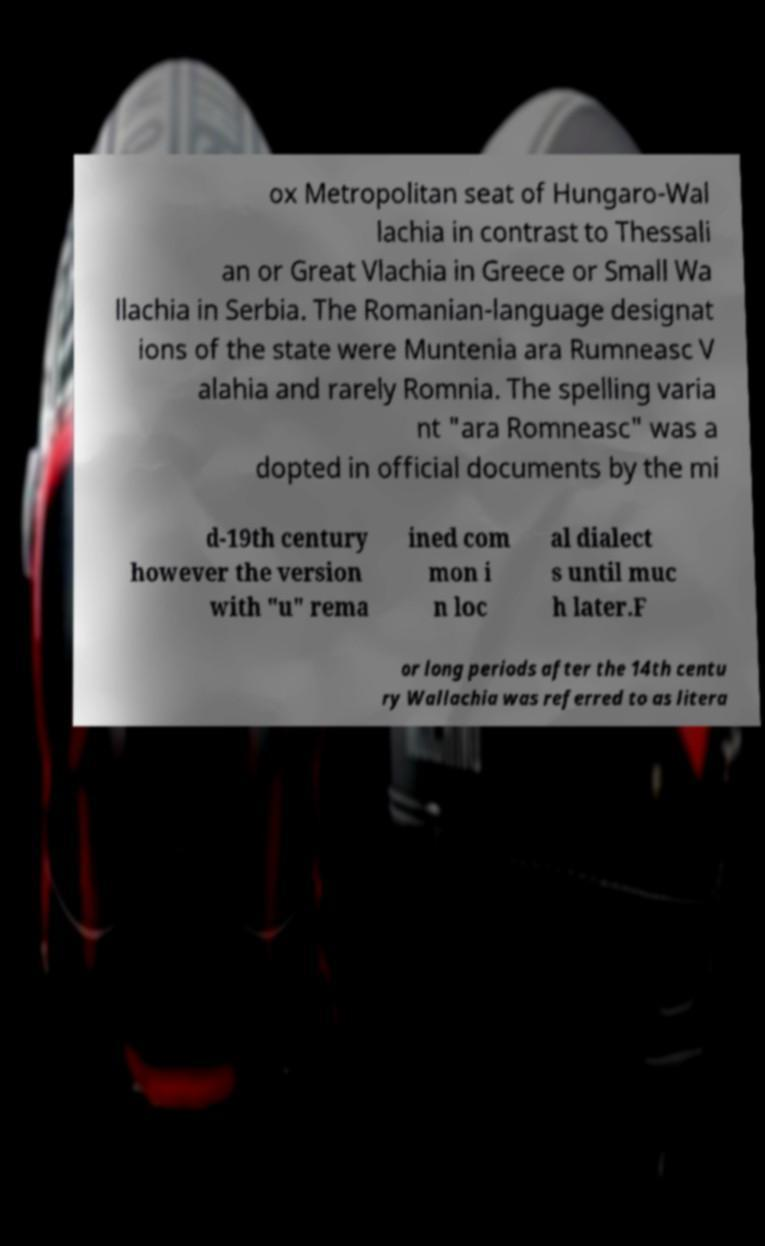What messages or text are displayed in this image? I need them in a readable, typed format. ox Metropolitan seat of Hungaro-Wal lachia in contrast to Thessali an or Great Vlachia in Greece or Small Wa llachia in Serbia. The Romanian-language designat ions of the state were Muntenia ara Rumneasc V alahia and rarely Romnia. The spelling varia nt "ara Romneasc" was a dopted in official documents by the mi d-19th century however the version with "u" rema ined com mon i n loc al dialect s until muc h later.F or long periods after the 14th centu ry Wallachia was referred to as litera 